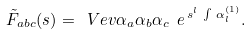<formula> <loc_0><loc_0><loc_500><loc_500>\tilde { F } _ { a b c } ( s ) = \ V e v { \alpha _ { a } \alpha _ { b } \alpha _ { c } \ e ^ { \, s ^ { l } \, \int \, \alpha _ { l } ^ { ( 1 ) } } } .</formula> 